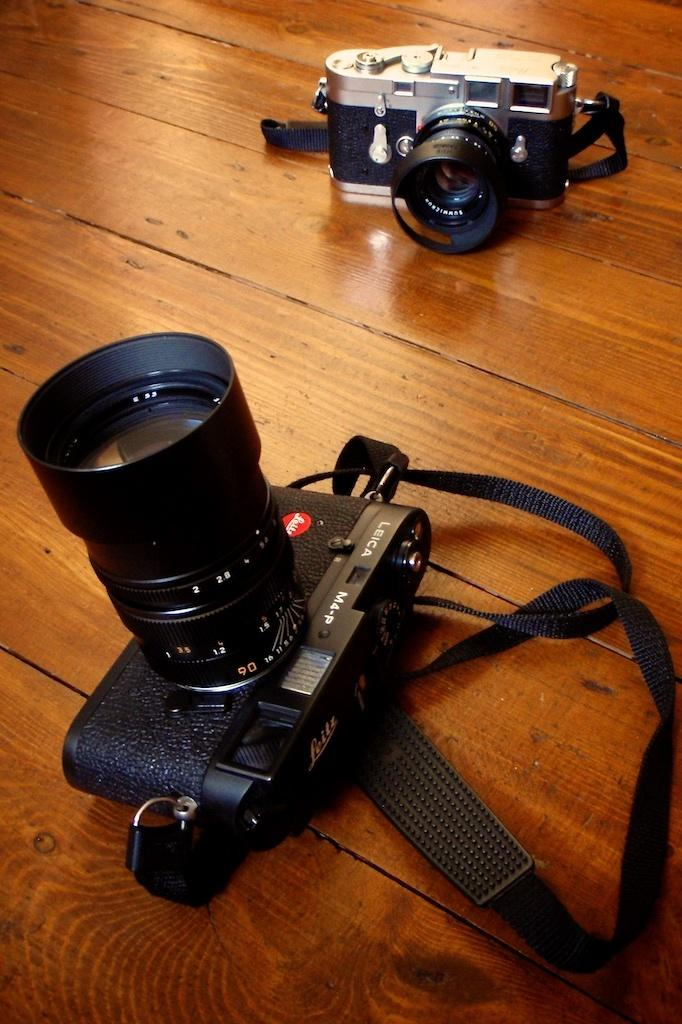What objects are present in the image? There are two cameras in the image. What is the color of the object on which the cameras are placed? The object is brown in color. What scientific experiment is being conducted with the cameras in the image? There is no indication of a scientific experiment being conducted in the image; it simply shows two cameras placed on a brown object. 